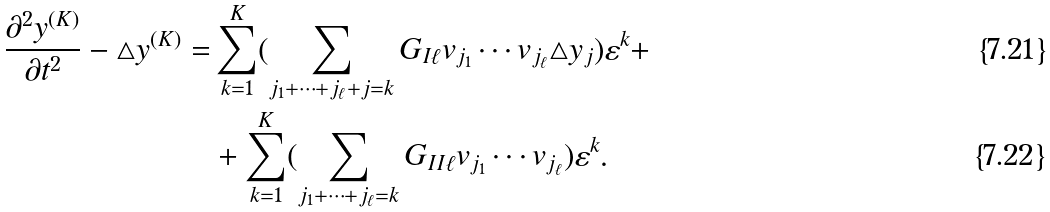<formula> <loc_0><loc_0><loc_500><loc_500>\frac { \partial ^ { 2 } y ^ { ( K ) } } { \partial t ^ { 2 } } - \triangle y ^ { ( K ) } = & \sum _ { k = 1 } ^ { K } ( \sum _ { j _ { 1 } + \cdots + j _ { \ell } + j = k } G _ { I \ell } v _ { j _ { 1 } } \cdots v _ { j _ { \ell } } \triangle y _ { j } ) \varepsilon ^ { k } + \\ & + \sum _ { k = 1 } ^ { K } ( \sum _ { j _ { 1 } + \cdots + j _ { \ell } = k } G _ { I I \ell } v _ { j _ { 1 } } \cdots v _ { j _ { \ell } } ) \varepsilon ^ { k } .</formula> 